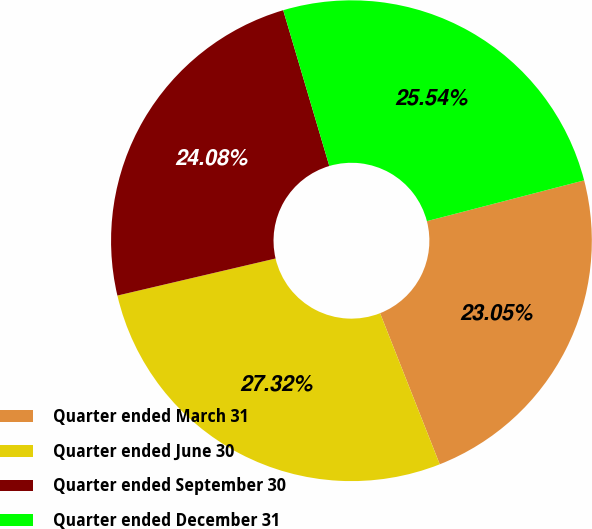<chart> <loc_0><loc_0><loc_500><loc_500><pie_chart><fcel>Quarter ended March 31<fcel>Quarter ended June 30<fcel>Quarter ended September 30<fcel>Quarter ended December 31<nl><fcel>23.05%<fcel>27.32%<fcel>24.08%<fcel>25.54%<nl></chart> 